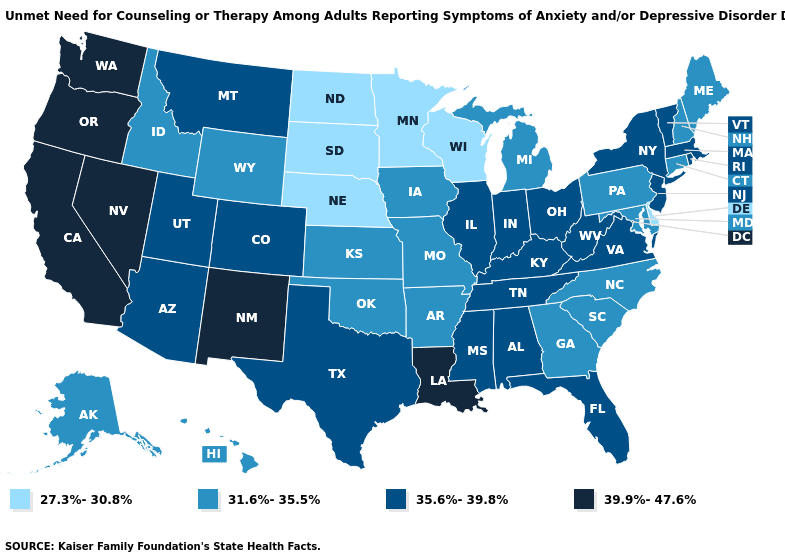Name the states that have a value in the range 35.6%-39.8%?
Be succinct. Alabama, Arizona, Colorado, Florida, Illinois, Indiana, Kentucky, Massachusetts, Mississippi, Montana, New Jersey, New York, Ohio, Rhode Island, Tennessee, Texas, Utah, Vermont, Virginia, West Virginia. Is the legend a continuous bar?
Write a very short answer. No. Does Massachusetts have the highest value in the Northeast?
Concise answer only. Yes. Does Arkansas have the same value as Minnesota?
Short answer required. No. What is the lowest value in the USA?
Concise answer only. 27.3%-30.8%. Does Vermont have the same value as Alabama?
Write a very short answer. Yes. Among the states that border Louisiana , does Mississippi have the highest value?
Concise answer only. Yes. What is the value of Maine?
Write a very short answer. 31.6%-35.5%. Does New Mexico have the same value as Michigan?
Quick response, please. No. Does Louisiana have the highest value in the USA?
Concise answer only. Yes. Does Louisiana have the highest value in the South?
Be succinct. Yes. What is the value of New York?
Keep it brief. 35.6%-39.8%. Does South Dakota have the lowest value in the USA?
Write a very short answer. Yes. Name the states that have a value in the range 27.3%-30.8%?
Be succinct. Delaware, Minnesota, Nebraska, North Dakota, South Dakota, Wisconsin. Which states hav the highest value in the West?
Quick response, please. California, Nevada, New Mexico, Oregon, Washington. 